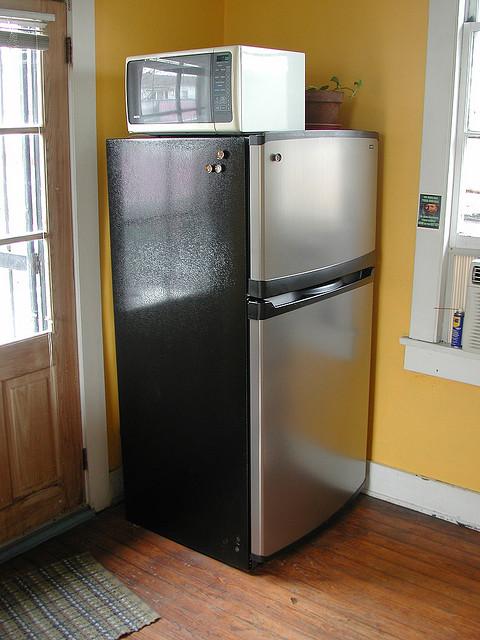What is on top of the refrigerator?
Be succinct. Microwave. How many windows shown?
Answer briefly. 2. What material is covering the floor?
Keep it brief. Wood. 